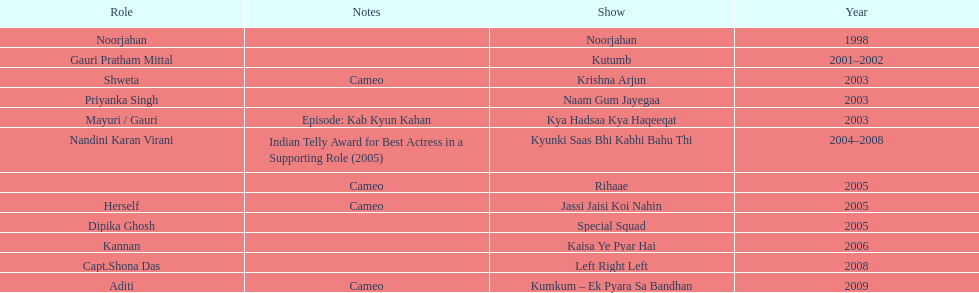What was the most years a show lasted? 4. 